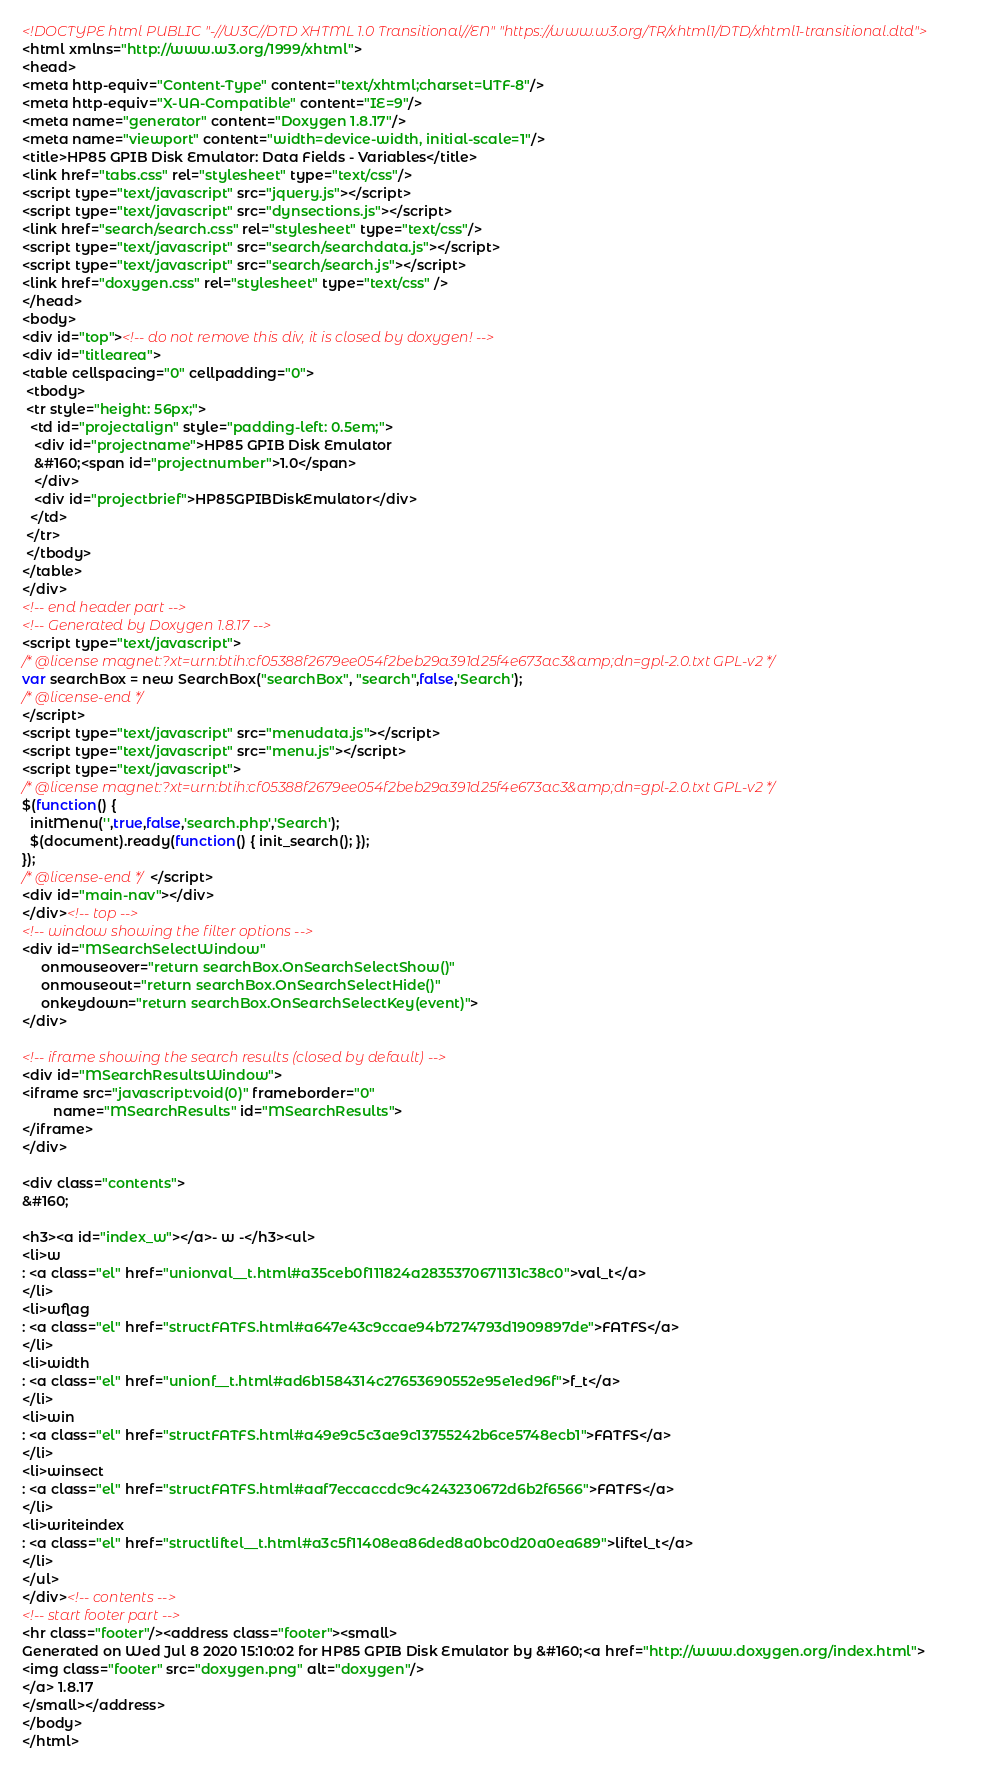Convert code to text. <code><loc_0><loc_0><loc_500><loc_500><_HTML_><!DOCTYPE html PUBLIC "-//W3C//DTD XHTML 1.0 Transitional//EN" "https://www.w3.org/TR/xhtml1/DTD/xhtml1-transitional.dtd">
<html xmlns="http://www.w3.org/1999/xhtml">
<head>
<meta http-equiv="Content-Type" content="text/xhtml;charset=UTF-8"/>
<meta http-equiv="X-UA-Compatible" content="IE=9"/>
<meta name="generator" content="Doxygen 1.8.17"/>
<meta name="viewport" content="width=device-width, initial-scale=1"/>
<title>HP85 GPIB Disk Emulator: Data Fields - Variables</title>
<link href="tabs.css" rel="stylesheet" type="text/css"/>
<script type="text/javascript" src="jquery.js"></script>
<script type="text/javascript" src="dynsections.js"></script>
<link href="search/search.css" rel="stylesheet" type="text/css"/>
<script type="text/javascript" src="search/searchdata.js"></script>
<script type="text/javascript" src="search/search.js"></script>
<link href="doxygen.css" rel="stylesheet" type="text/css" />
</head>
<body>
<div id="top"><!-- do not remove this div, it is closed by doxygen! -->
<div id="titlearea">
<table cellspacing="0" cellpadding="0">
 <tbody>
 <tr style="height: 56px;">
  <td id="projectalign" style="padding-left: 0.5em;">
   <div id="projectname">HP85 GPIB Disk Emulator
   &#160;<span id="projectnumber">1.0</span>
   </div>
   <div id="projectbrief">HP85GPIBDiskEmulator</div>
  </td>
 </tr>
 </tbody>
</table>
</div>
<!-- end header part -->
<!-- Generated by Doxygen 1.8.17 -->
<script type="text/javascript">
/* @license magnet:?xt=urn:btih:cf05388f2679ee054f2beb29a391d25f4e673ac3&amp;dn=gpl-2.0.txt GPL-v2 */
var searchBox = new SearchBox("searchBox", "search",false,'Search');
/* @license-end */
</script>
<script type="text/javascript" src="menudata.js"></script>
<script type="text/javascript" src="menu.js"></script>
<script type="text/javascript">
/* @license magnet:?xt=urn:btih:cf05388f2679ee054f2beb29a391d25f4e673ac3&amp;dn=gpl-2.0.txt GPL-v2 */
$(function() {
  initMenu('',true,false,'search.php','Search');
  $(document).ready(function() { init_search(); });
});
/* @license-end */</script>
<div id="main-nav"></div>
</div><!-- top -->
<!-- window showing the filter options -->
<div id="MSearchSelectWindow"
     onmouseover="return searchBox.OnSearchSelectShow()"
     onmouseout="return searchBox.OnSearchSelectHide()"
     onkeydown="return searchBox.OnSearchSelectKey(event)">
</div>

<!-- iframe showing the search results (closed by default) -->
<div id="MSearchResultsWindow">
<iframe src="javascript:void(0)" frameborder="0" 
        name="MSearchResults" id="MSearchResults">
</iframe>
</div>

<div class="contents">
&#160;

<h3><a id="index_w"></a>- w -</h3><ul>
<li>w
: <a class="el" href="unionval__t.html#a35ceb0f111824a2835370671131c38c0">val_t</a>
</li>
<li>wflag
: <a class="el" href="structFATFS.html#a647e43c9ccae94b7274793d1909897de">FATFS</a>
</li>
<li>width
: <a class="el" href="unionf__t.html#ad6b1584314c27653690552e95e1ed96f">f_t</a>
</li>
<li>win
: <a class="el" href="structFATFS.html#a49e9c5c3ae9c13755242b6ce5748ecb1">FATFS</a>
</li>
<li>winsect
: <a class="el" href="structFATFS.html#aaf7eccaccdc9c4243230672d6b2f6566">FATFS</a>
</li>
<li>writeindex
: <a class="el" href="structliftel__t.html#a3c5f11408ea86ded8a0bc0d20a0ea689">liftel_t</a>
</li>
</ul>
</div><!-- contents -->
<!-- start footer part -->
<hr class="footer"/><address class="footer"><small>
Generated on Wed Jul 8 2020 15:10:02 for HP85 GPIB Disk Emulator by &#160;<a href="http://www.doxygen.org/index.html">
<img class="footer" src="doxygen.png" alt="doxygen"/>
</a> 1.8.17
</small></address>
</body>
</html>
</code> 